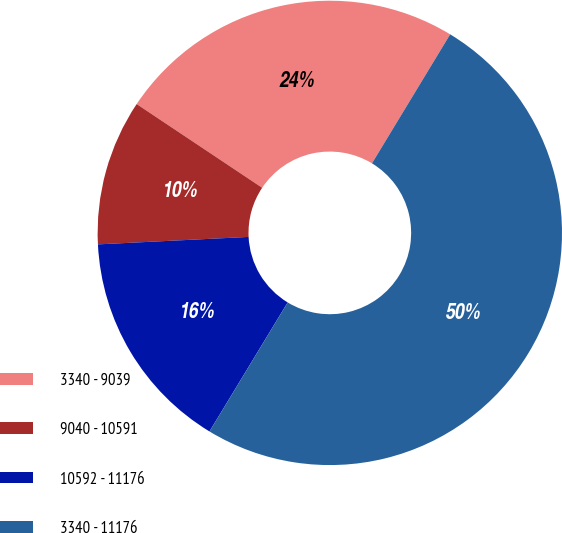Convert chart. <chart><loc_0><loc_0><loc_500><loc_500><pie_chart><fcel>3340 - 9039<fcel>9040 - 10591<fcel>10592 - 11176<fcel>3340 - 11176<nl><fcel>24.31%<fcel>10.15%<fcel>15.54%<fcel>50.0%<nl></chart> 